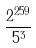<formula> <loc_0><loc_0><loc_500><loc_500>\frac { 2 ^ { 2 5 9 } } { 5 ^ { 3 } }</formula> 